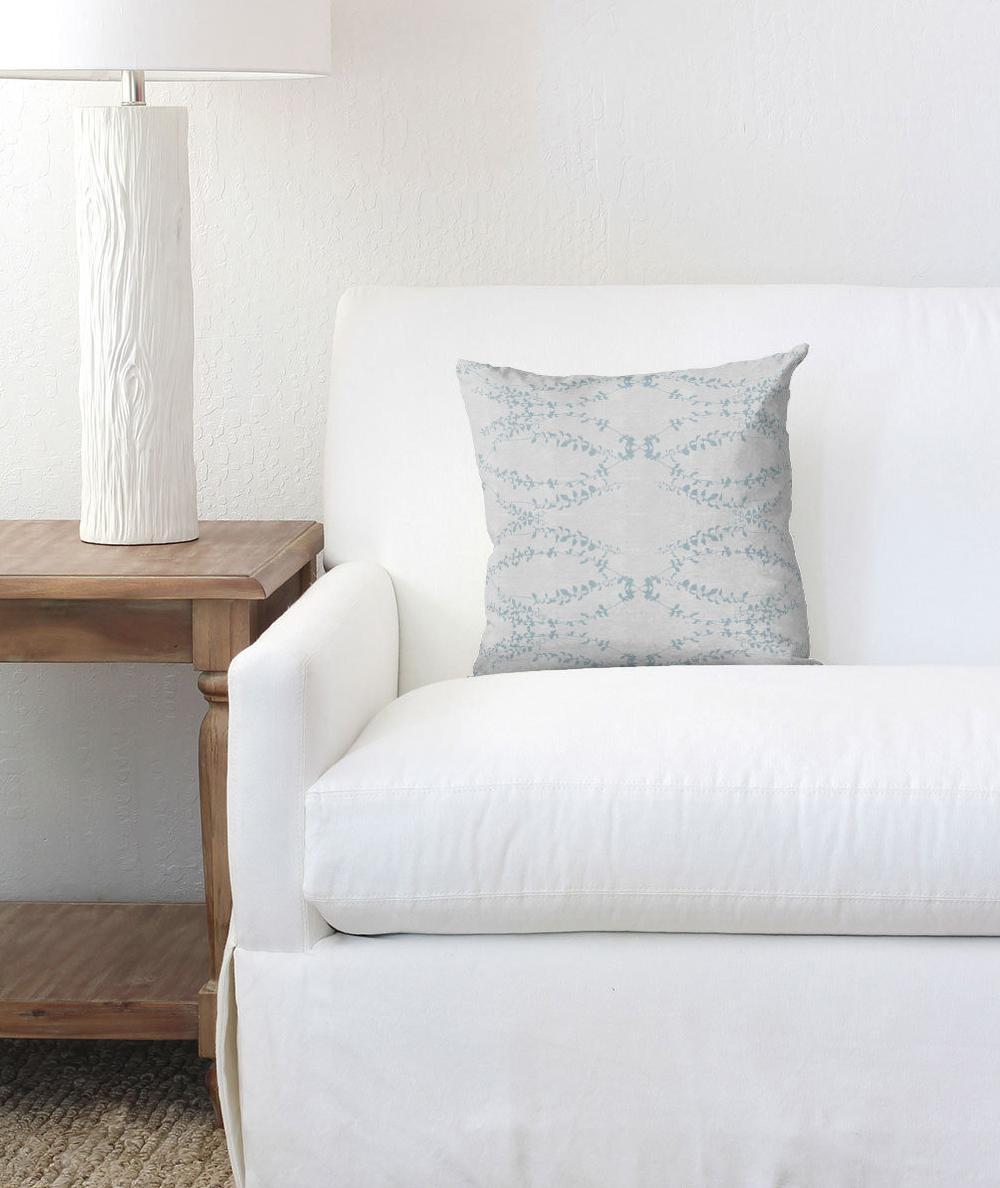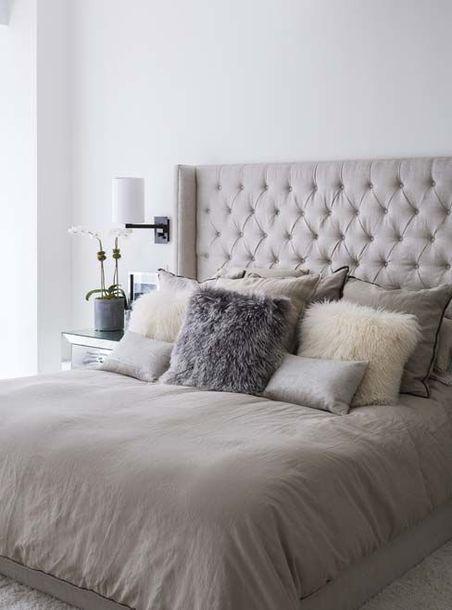The first image is the image on the left, the second image is the image on the right. Considering the images on both sides, is "Two beds, one of them much narrower than the other, have luxurious white and light-colored bedding and pillows." valid? Answer yes or no. No. The first image is the image on the left, the second image is the image on the right. Evaluate the accuracy of this statement regarding the images: "An image features a pillow-piled bed with a neutral-colored tufted headboard.". Is it true? Answer yes or no. Yes. 